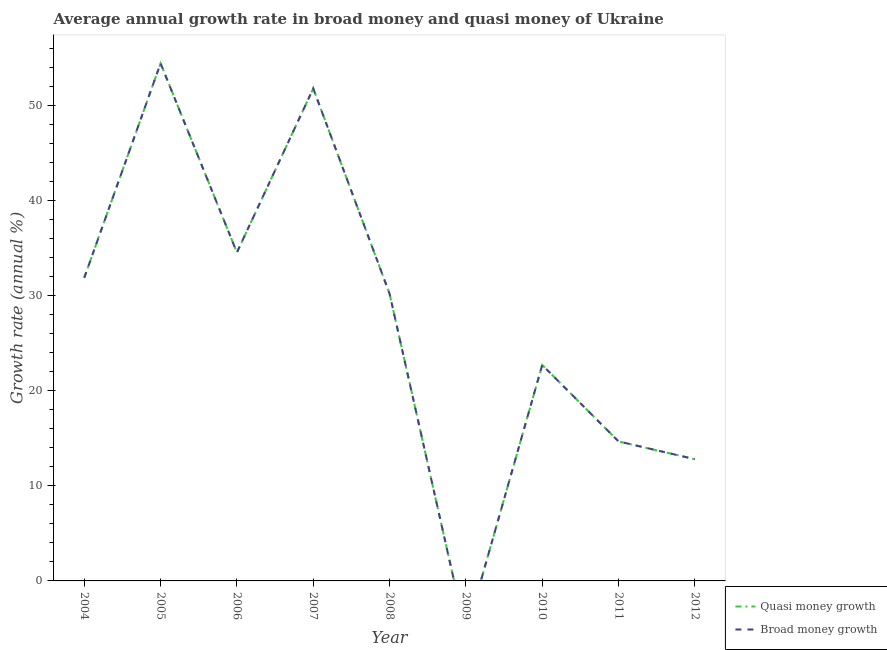How many different coloured lines are there?
Provide a succinct answer. 2. Is the number of lines equal to the number of legend labels?
Your answer should be very brief. No. What is the annual growth rate in quasi money in 2006?
Give a very brief answer. 34.52. Across all years, what is the maximum annual growth rate in quasi money?
Offer a very short reply. 54.39. Across all years, what is the minimum annual growth rate in quasi money?
Keep it short and to the point. 0. In which year was the annual growth rate in quasi money maximum?
Ensure brevity in your answer.  2005. What is the total annual growth rate in broad money in the graph?
Your answer should be compact. 252.83. What is the difference between the annual growth rate in broad money in 2006 and that in 2012?
Provide a short and direct response. 21.73. What is the difference between the annual growth rate in quasi money in 2007 and the annual growth rate in broad money in 2011?
Offer a very short reply. 37.09. What is the average annual growth rate in quasi money per year?
Your answer should be very brief. 28.09. What is the ratio of the annual growth rate in quasi money in 2006 to that in 2008?
Your answer should be very brief. 1.14. Is the annual growth rate in broad money in 2008 less than that in 2011?
Your answer should be compact. No. What is the difference between the highest and the second highest annual growth rate in broad money?
Your answer should be very brief. 2.64. What is the difference between the highest and the lowest annual growth rate in broad money?
Your response must be concise. 54.39. In how many years, is the annual growth rate in broad money greater than the average annual growth rate in broad money taken over all years?
Give a very brief answer. 5. Is the sum of the annual growth rate in quasi money in 2006 and 2007 greater than the maximum annual growth rate in broad money across all years?
Keep it short and to the point. Yes. Is the annual growth rate in broad money strictly greater than the annual growth rate in quasi money over the years?
Provide a short and direct response. No. Is the annual growth rate in broad money strictly less than the annual growth rate in quasi money over the years?
Provide a succinct answer. No. How many lines are there?
Offer a very short reply. 2. What is the difference between two consecutive major ticks on the Y-axis?
Provide a short and direct response. 10. What is the title of the graph?
Provide a short and direct response. Average annual growth rate in broad money and quasi money of Ukraine. Does "Short-term debt" appear as one of the legend labels in the graph?
Make the answer very short. No. What is the label or title of the Y-axis?
Offer a terse response. Growth rate (annual %). What is the Growth rate (annual %) in Quasi money growth in 2004?
Your answer should be compact. 31.86. What is the Growth rate (annual %) of Broad money growth in 2004?
Your response must be concise. 31.86. What is the Growth rate (annual %) in Quasi money growth in 2005?
Your response must be concise. 54.39. What is the Growth rate (annual %) of Broad money growth in 2005?
Make the answer very short. 54.39. What is the Growth rate (annual %) of Quasi money growth in 2006?
Your answer should be very brief. 34.52. What is the Growth rate (annual %) in Broad money growth in 2006?
Your response must be concise. 34.52. What is the Growth rate (annual %) of Quasi money growth in 2007?
Your response must be concise. 51.75. What is the Growth rate (annual %) in Broad money growth in 2007?
Your answer should be very brief. 51.75. What is the Growth rate (annual %) of Quasi money growth in 2008?
Your answer should be compact. 30.18. What is the Growth rate (annual %) of Broad money growth in 2008?
Offer a terse response. 30.18. What is the Growth rate (annual %) in Quasi money growth in 2010?
Keep it short and to the point. 22.69. What is the Growth rate (annual %) of Broad money growth in 2010?
Ensure brevity in your answer.  22.69. What is the Growth rate (annual %) of Quasi money growth in 2011?
Make the answer very short. 14.66. What is the Growth rate (annual %) in Broad money growth in 2011?
Give a very brief answer. 14.66. What is the Growth rate (annual %) of Quasi money growth in 2012?
Provide a succinct answer. 12.79. What is the Growth rate (annual %) in Broad money growth in 2012?
Provide a succinct answer. 12.79. Across all years, what is the maximum Growth rate (annual %) in Quasi money growth?
Your answer should be very brief. 54.39. Across all years, what is the maximum Growth rate (annual %) of Broad money growth?
Provide a succinct answer. 54.39. Across all years, what is the minimum Growth rate (annual %) of Quasi money growth?
Give a very brief answer. 0. Across all years, what is the minimum Growth rate (annual %) of Broad money growth?
Offer a terse response. 0. What is the total Growth rate (annual %) of Quasi money growth in the graph?
Ensure brevity in your answer.  252.83. What is the total Growth rate (annual %) of Broad money growth in the graph?
Offer a very short reply. 252.83. What is the difference between the Growth rate (annual %) of Quasi money growth in 2004 and that in 2005?
Provide a short and direct response. -22.53. What is the difference between the Growth rate (annual %) in Broad money growth in 2004 and that in 2005?
Give a very brief answer. -22.53. What is the difference between the Growth rate (annual %) in Quasi money growth in 2004 and that in 2006?
Your response must be concise. -2.66. What is the difference between the Growth rate (annual %) in Broad money growth in 2004 and that in 2006?
Your response must be concise. -2.66. What is the difference between the Growth rate (annual %) of Quasi money growth in 2004 and that in 2007?
Your answer should be compact. -19.89. What is the difference between the Growth rate (annual %) of Broad money growth in 2004 and that in 2007?
Offer a terse response. -19.89. What is the difference between the Growth rate (annual %) of Quasi money growth in 2004 and that in 2008?
Provide a succinct answer. 1.67. What is the difference between the Growth rate (annual %) of Broad money growth in 2004 and that in 2008?
Your answer should be very brief. 1.67. What is the difference between the Growth rate (annual %) of Quasi money growth in 2004 and that in 2010?
Your response must be concise. 9.17. What is the difference between the Growth rate (annual %) in Broad money growth in 2004 and that in 2010?
Offer a terse response. 9.17. What is the difference between the Growth rate (annual %) of Quasi money growth in 2004 and that in 2011?
Provide a short and direct response. 17.2. What is the difference between the Growth rate (annual %) of Broad money growth in 2004 and that in 2011?
Keep it short and to the point. 17.2. What is the difference between the Growth rate (annual %) of Quasi money growth in 2004 and that in 2012?
Your answer should be compact. 19.07. What is the difference between the Growth rate (annual %) of Broad money growth in 2004 and that in 2012?
Ensure brevity in your answer.  19.07. What is the difference between the Growth rate (annual %) of Quasi money growth in 2005 and that in 2006?
Your answer should be compact. 19.87. What is the difference between the Growth rate (annual %) in Broad money growth in 2005 and that in 2006?
Offer a very short reply. 19.87. What is the difference between the Growth rate (annual %) in Quasi money growth in 2005 and that in 2007?
Give a very brief answer. 2.64. What is the difference between the Growth rate (annual %) in Broad money growth in 2005 and that in 2007?
Your answer should be compact. 2.64. What is the difference between the Growth rate (annual %) in Quasi money growth in 2005 and that in 2008?
Keep it short and to the point. 24.2. What is the difference between the Growth rate (annual %) of Broad money growth in 2005 and that in 2008?
Provide a short and direct response. 24.2. What is the difference between the Growth rate (annual %) in Quasi money growth in 2005 and that in 2010?
Give a very brief answer. 31.69. What is the difference between the Growth rate (annual %) in Broad money growth in 2005 and that in 2010?
Provide a short and direct response. 31.69. What is the difference between the Growth rate (annual %) of Quasi money growth in 2005 and that in 2011?
Ensure brevity in your answer.  39.73. What is the difference between the Growth rate (annual %) of Broad money growth in 2005 and that in 2011?
Give a very brief answer. 39.73. What is the difference between the Growth rate (annual %) of Quasi money growth in 2005 and that in 2012?
Keep it short and to the point. 41.59. What is the difference between the Growth rate (annual %) in Broad money growth in 2005 and that in 2012?
Offer a very short reply. 41.59. What is the difference between the Growth rate (annual %) in Quasi money growth in 2006 and that in 2007?
Your response must be concise. -17.23. What is the difference between the Growth rate (annual %) of Broad money growth in 2006 and that in 2007?
Offer a terse response. -17.23. What is the difference between the Growth rate (annual %) of Quasi money growth in 2006 and that in 2008?
Your answer should be very brief. 4.34. What is the difference between the Growth rate (annual %) in Broad money growth in 2006 and that in 2008?
Offer a very short reply. 4.34. What is the difference between the Growth rate (annual %) in Quasi money growth in 2006 and that in 2010?
Give a very brief answer. 11.83. What is the difference between the Growth rate (annual %) of Broad money growth in 2006 and that in 2010?
Provide a succinct answer. 11.83. What is the difference between the Growth rate (annual %) of Quasi money growth in 2006 and that in 2011?
Your response must be concise. 19.86. What is the difference between the Growth rate (annual %) in Broad money growth in 2006 and that in 2011?
Keep it short and to the point. 19.86. What is the difference between the Growth rate (annual %) in Quasi money growth in 2006 and that in 2012?
Provide a succinct answer. 21.73. What is the difference between the Growth rate (annual %) of Broad money growth in 2006 and that in 2012?
Give a very brief answer. 21.73. What is the difference between the Growth rate (annual %) of Quasi money growth in 2007 and that in 2008?
Keep it short and to the point. 21.56. What is the difference between the Growth rate (annual %) of Broad money growth in 2007 and that in 2008?
Your answer should be very brief. 21.56. What is the difference between the Growth rate (annual %) of Quasi money growth in 2007 and that in 2010?
Provide a succinct answer. 29.06. What is the difference between the Growth rate (annual %) in Broad money growth in 2007 and that in 2010?
Make the answer very short. 29.06. What is the difference between the Growth rate (annual %) in Quasi money growth in 2007 and that in 2011?
Your answer should be very brief. 37.09. What is the difference between the Growth rate (annual %) of Broad money growth in 2007 and that in 2011?
Give a very brief answer. 37.09. What is the difference between the Growth rate (annual %) in Quasi money growth in 2007 and that in 2012?
Give a very brief answer. 38.96. What is the difference between the Growth rate (annual %) of Broad money growth in 2007 and that in 2012?
Provide a succinct answer. 38.96. What is the difference between the Growth rate (annual %) of Quasi money growth in 2008 and that in 2010?
Offer a very short reply. 7.49. What is the difference between the Growth rate (annual %) of Broad money growth in 2008 and that in 2010?
Offer a very short reply. 7.49. What is the difference between the Growth rate (annual %) of Quasi money growth in 2008 and that in 2011?
Ensure brevity in your answer.  15.52. What is the difference between the Growth rate (annual %) in Broad money growth in 2008 and that in 2011?
Make the answer very short. 15.52. What is the difference between the Growth rate (annual %) of Quasi money growth in 2008 and that in 2012?
Make the answer very short. 17.39. What is the difference between the Growth rate (annual %) of Broad money growth in 2008 and that in 2012?
Your answer should be compact. 17.39. What is the difference between the Growth rate (annual %) in Quasi money growth in 2010 and that in 2011?
Offer a terse response. 8.03. What is the difference between the Growth rate (annual %) in Broad money growth in 2010 and that in 2011?
Your answer should be compact. 8.03. What is the difference between the Growth rate (annual %) in Quasi money growth in 2010 and that in 2012?
Your answer should be compact. 9.9. What is the difference between the Growth rate (annual %) of Broad money growth in 2010 and that in 2012?
Give a very brief answer. 9.9. What is the difference between the Growth rate (annual %) of Quasi money growth in 2011 and that in 2012?
Your response must be concise. 1.87. What is the difference between the Growth rate (annual %) in Broad money growth in 2011 and that in 2012?
Provide a short and direct response. 1.87. What is the difference between the Growth rate (annual %) in Quasi money growth in 2004 and the Growth rate (annual %) in Broad money growth in 2005?
Your response must be concise. -22.53. What is the difference between the Growth rate (annual %) of Quasi money growth in 2004 and the Growth rate (annual %) of Broad money growth in 2006?
Offer a terse response. -2.66. What is the difference between the Growth rate (annual %) in Quasi money growth in 2004 and the Growth rate (annual %) in Broad money growth in 2007?
Provide a short and direct response. -19.89. What is the difference between the Growth rate (annual %) in Quasi money growth in 2004 and the Growth rate (annual %) in Broad money growth in 2008?
Give a very brief answer. 1.67. What is the difference between the Growth rate (annual %) in Quasi money growth in 2004 and the Growth rate (annual %) in Broad money growth in 2010?
Ensure brevity in your answer.  9.17. What is the difference between the Growth rate (annual %) in Quasi money growth in 2004 and the Growth rate (annual %) in Broad money growth in 2011?
Your answer should be compact. 17.2. What is the difference between the Growth rate (annual %) of Quasi money growth in 2004 and the Growth rate (annual %) of Broad money growth in 2012?
Make the answer very short. 19.07. What is the difference between the Growth rate (annual %) of Quasi money growth in 2005 and the Growth rate (annual %) of Broad money growth in 2006?
Your answer should be very brief. 19.87. What is the difference between the Growth rate (annual %) of Quasi money growth in 2005 and the Growth rate (annual %) of Broad money growth in 2007?
Your response must be concise. 2.64. What is the difference between the Growth rate (annual %) of Quasi money growth in 2005 and the Growth rate (annual %) of Broad money growth in 2008?
Offer a very short reply. 24.2. What is the difference between the Growth rate (annual %) of Quasi money growth in 2005 and the Growth rate (annual %) of Broad money growth in 2010?
Your response must be concise. 31.69. What is the difference between the Growth rate (annual %) of Quasi money growth in 2005 and the Growth rate (annual %) of Broad money growth in 2011?
Your answer should be very brief. 39.73. What is the difference between the Growth rate (annual %) of Quasi money growth in 2005 and the Growth rate (annual %) of Broad money growth in 2012?
Keep it short and to the point. 41.59. What is the difference between the Growth rate (annual %) in Quasi money growth in 2006 and the Growth rate (annual %) in Broad money growth in 2007?
Provide a short and direct response. -17.23. What is the difference between the Growth rate (annual %) of Quasi money growth in 2006 and the Growth rate (annual %) of Broad money growth in 2008?
Provide a succinct answer. 4.34. What is the difference between the Growth rate (annual %) of Quasi money growth in 2006 and the Growth rate (annual %) of Broad money growth in 2010?
Offer a terse response. 11.83. What is the difference between the Growth rate (annual %) in Quasi money growth in 2006 and the Growth rate (annual %) in Broad money growth in 2011?
Your response must be concise. 19.86. What is the difference between the Growth rate (annual %) of Quasi money growth in 2006 and the Growth rate (annual %) of Broad money growth in 2012?
Your answer should be very brief. 21.73. What is the difference between the Growth rate (annual %) of Quasi money growth in 2007 and the Growth rate (annual %) of Broad money growth in 2008?
Your response must be concise. 21.56. What is the difference between the Growth rate (annual %) in Quasi money growth in 2007 and the Growth rate (annual %) in Broad money growth in 2010?
Offer a terse response. 29.06. What is the difference between the Growth rate (annual %) of Quasi money growth in 2007 and the Growth rate (annual %) of Broad money growth in 2011?
Offer a very short reply. 37.09. What is the difference between the Growth rate (annual %) in Quasi money growth in 2007 and the Growth rate (annual %) in Broad money growth in 2012?
Your answer should be very brief. 38.96. What is the difference between the Growth rate (annual %) of Quasi money growth in 2008 and the Growth rate (annual %) of Broad money growth in 2010?
Your answer should be very brief. 7.49. What is the difference between the Growth rate (annual %) in Quasi money growth in 2008 and the Growth rate (annual %) in Broad money growth in 2011?
Your answer should be compact. 15.52. What is the difference between the Growth rate (annual %) in Quasi money growth in 2008 and the Growth rate (annual %) in Broad money growth in 2012?
Your response must be concise. 17.39. What is the difference between the Growth rate (annual %) in Quasi money growth in 2010 and the Growth rate (annual %) in Broad money growth in 2011?
Provide a succinct answer. 8.03. What is the difference between the Growth rate (annual %) of Quasi money growth in 2010 and the Growth rate (annual %) of Broad money growth in 2012?
Give a very brief answer. 9.9. What is the difference between the Growth rate (annual %) of Quasi money growth in 2011 and the Growth rate (annual %) of Broad money growth in 2012?
Make the answer very short. 1.87. What is the average Growth rate (annual %) of Quasi money growth per year?
Your answer should be very brief. 28.09. What is the average Growth rate (annual %) in Broad money growth per year?
Give a very brief answer. 28.09. In the year 2012, what is the difference between the Growth rate (annual %) in Quasi money growth and Growth rate (annual %) in Broad money growth?
Offer a terse response. 0. What is the ratio of the Growth rate (annual %) of Quasi money growth in 2004 to that in 2005?
Provide a short and direct response. 0.59. What is the ratio of the Growth rate (annual %) in Broad money growth in 2004 to that in 2005?
Keep it short and to the point. 0.59. What is the ratio of the Growth rate (annual %) in Quasi money growth in 2004 to that in 2006?
Your response must be concise. 0.92. What is the ratio of the Growth rate (annual %) in Broad money growth in 2004 to that in 2006?
Offer a very short reply. 0.92. What is the ratio of the Growth rate (annual %) in Quasi money growth in 2004 to that in 2007?
Your answer should be very brief. 0.62. What is the ratio of the Growth rate (annual %) of Broad money growth in 2004 to that in 2007?
Provide a short and direct response. 0.62. What is the ratio of the Growth rate (annual %) of Quasi money growth in 2004 to that in 2008?
Provide a succinct answer. 1.06. What is the ratio of the Growth rate (annual %) in Broad money growth in 2004 to that in 2008?
Offer a very short reply. 1.06. What is the ratio of the Growth rate (annual %) in Quasi money growth in 2004 to that in 2010?
Give a very brief answer. 1.4. What is the ratio of the Growth rate (annual %) of Broad money growth in 2004 to that in 2010?
Give a very brief answer. 1.4. What is the ratio of the Growth rate (annual %) of Quasi money growth in 2004 to that in 2011?
Provide a short and direct response. 2.17. What is the ratio of the Growth rate (annual %) of Broad money growth in 2004 to that in 2011?
Offer a terse response. 2.17. What is the ratio of the Growth rate (annual %) of Quasi money growth in 2004 to that in 2012?
Provide a short and direct response. 2.49. What is the ratio of the Growth rate (annual %) of Broad money growth in 2004 to that in 2012?
Provide a succinct answer. 2.49. What is the ratio of the Growth rate (annual %) of Quasi money growth in 2005 to that in 2006?
Offer a terse response. 1.58. What is the ratio of the Growth rate (annual %) in Broad money growth in 2005 to that in 2006?
Provide a short and direct response. 1.58. What is the ratio of the Growth rate (annual %) of Quasi money growth in 2005 to that in 2007?
Keep it short and to the point. 1.05. What is the ratio of the Growth rate (annual %) in Broad money growth in 2005 to that in 2007?
Your answer should be compact. 1.05. What is the ratio of the Growth rate (annual %) in Quasi money growth in 2005 to that in 2008?
Your answer should be compact. 1.8. What is the ratio of the Growth rate (annual %) of Broad money growth in 2005 to that in 2008?
Your response must be concise. 1.8. What is the ratio of the Growth rate (annual %) of Quasi money growth in 2005 to that in 2010?
Offer a very short reply. 2.4. What is the ratio of the Growth rate (annual %) in Broad money growth in 2005 to that in 2010?
Provide a succinct answer. 2.4. What is the ratio of the Growth rate (annual %) in Quasi money growth in 2005 to that in 2011?
Offer a very short reply. 3.71. What is the ratio of the Growth rate (annual %) of Broad money growth in 2005 to that in 2011?
Ensure brevity in your answer.  3.71. What is the ratio of the Growth rate (annual %) in Quasi money growth in 2005 to that in 2012?
Keep it short and to the point. 4.25. What is the ratio of the Growth rate (annual %) of Broad money growth in 2005 to that in 2012?
Your response must be concise. 4.25. What is the ratio of the Growth rate (annual %) in Quasi money growth in 2006 to that in 2007?
Offer a terse response. 0.67. What is the ratio of the Growth rate (annual %) in Broad money growth in 2006 to that in 2007?
Provide a short and direct response. 0.67. What is the ratio of the Growth rate (annual %) in Quasi money growth in 2006 to that in 2008?
Offer a terse response. 1.14. What is the ratio of the Growth rate (annual %) of Broad money growth in 2006 to that in 2008?
Your answer should be compact. 1.14. What is the ratio of the Growth rate (annual %) of Quasi money growth in 2006 to that in 2010?
Offer a terse response. 1.52. What is the ratio of the Growth rate (annual %) in Broad money growth in 2006 to that in 2010?
Provide a short and direct response. 1.52. What is the ratio of the Growth rate (annual %) of Quasi money growth in 2006 to that in 2011?
Ensure brevity in your answer.  2.35. What is the ratio of the Growth rate (annual %) in Broad money growth in 2006 to that in 2011?
Keep it short and to the point. 2.35. What is the ratio of the Growth rate (annual %) of Quasi money growth in 2006 to that in 2012?
Offer a terse response. 2.7. What is the ratio of the Growth rate (annual %) of Broad money growth in 2006 to that in 2012?
Make the answer very short. 2.7. What is the ratio of the Growth rate (annual %) in Quasi money growth in 2007 to that in 2008?
Offer a terse response. 1.71. What is the ratio of the Growth rate (annual %) in Broad money growth in 2007 to that in 2008?
Your response must be concise. 1.71. What is the ratio of the Growth rate (annual %) of Quasi money growth in 2007 to that in 2010?
Keep it short and to the point. 2.28. What is the ratio of the Growth rate (annual %) of Broad money growth in 2007 to that in 2010?
Provide a short and direct response. 2.28. What is the ratio of the Growth rate (annual %) in Quasi money growth in 2007 to that in 2011?
Provide a short and direct response. 3.53. What is the ratio of the Growth rate (annual %) of Broad money growth in 2007 to that in 2011?
Keep it short and to the point. 3.53. What is the ratio of the Growth rate (annual %) of Quasi money growth in 2007 to that in 2012?
Provide a succinct answer. 4.05. What is the ratio of the Growth rate (annual %) in Broad money growth in 2007 to that in 2012?
Make the answer very short. 4.05. What is the ratio of the Growth rate (annual %) in Quasi money growth in 2008 to that in 2010?
Provide a short and direct response. 1.33. What is the ratio of the Growth rate (annual %) in Broad money growth in 2008 to that in 2010?
Make the answer very short. 1.33. What is the ratio of the Growth rate (annual %) of Quasi money growth in 2008 to that in 2011?
Keep it short and to the point. 2.06. What is the ratio of the Growth rate (annual %) in Broad money growth in 2008 to that in 2011?
Provide a succinct answer. 2.06. What is the ratio of the Growth rate (annual %) of Quasi money growth in 2008 to that in 2012?
Ensure brevity in your answer.  2.36. What is the ratio of the Growth rate (annual %) in Broad money growth in 2008 to that in 2012?
Offer a terse response. 2.36. What is the ratio of the Growth rate (annual %) in Quasi money growth in 2010 to that in 2011?
Ensure brevity in your answer.  1.55. What is the ratio of the Growth rate (annual %) in Broad money growth in 2010 to that in 2011?
Provide a short and direct response. 1.55. What is the ratio of the Growth rate (annual %) of Quasi money growth in 2010 to that in 2012?
Keep it short and to the point. 1.77. What is the ratio of the Growth rate (annual %) in Broad money growth in 2010 to that in 2012?
Ensure brevity in your answer.  1.77. What is the ratio of the Growth rate (annual %) of Quasi money growth in 2011 to that in 2012?
Your response must be concise. 1.15. What is the ratio of the Growth rate (annual %) in Broad money growth in 2011 to that in 2012?
Your answer should be compact. 1.15. What is the difference between the highest and the second highest Growth rate (annual %) of Quasi money growth?
Your answer should be very brief. 2.64. What is the difference between the highest and the second highest Growth rate (annual %) of Broad money growth?
Your answer should be compact. 2.64. What is the difference between the highest and the lowest Growth rate (annual %) of Quasi money growth?
Offer a very short reply. 54.39. What is the difference between the highest and the lowest Growth rate (annual %) of Broad money growth?
Make the answer very short. 54.39. 